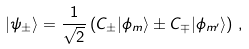<formula> <loc_0><loc_0><loc_500><loc_500>| \psi _ { \pm } \rangle = \frac { 1 } { \sqrt { 2 } } \left ( C _ { \pm } | \phi _ { m } \rangle \pm C _ { \mp } | \phi _ { m ^ { \prime } } \rangle \right ) \, ,</formula> 